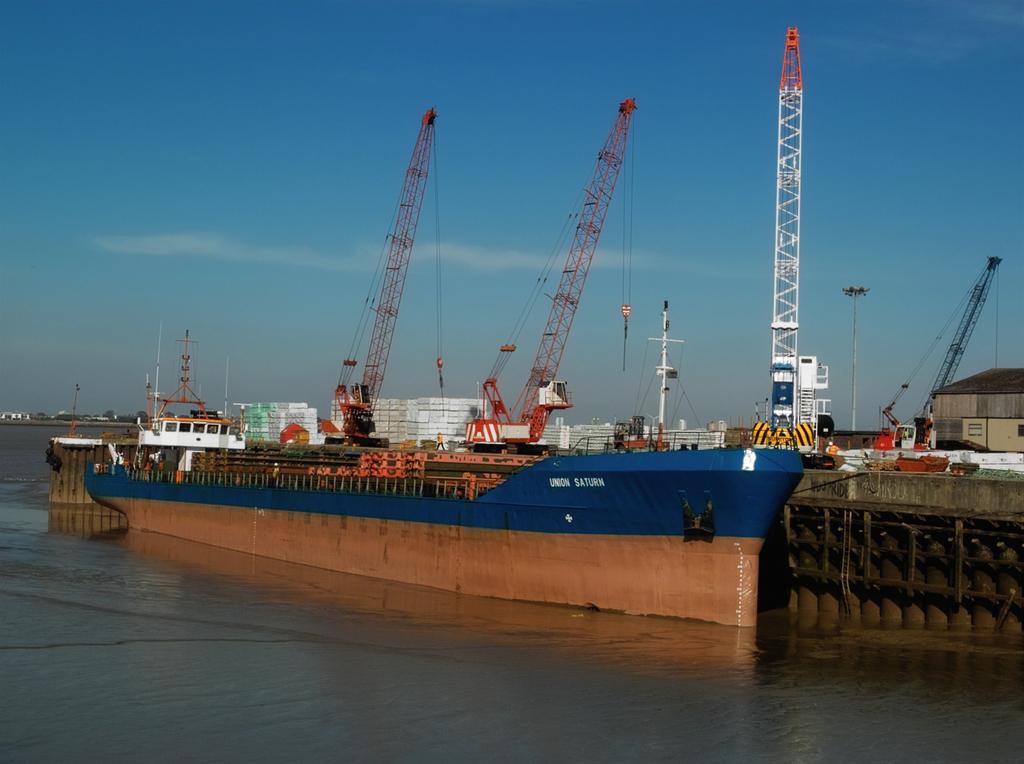Describe this image in one or two sentences. In this picture we can see a ship in the water. 